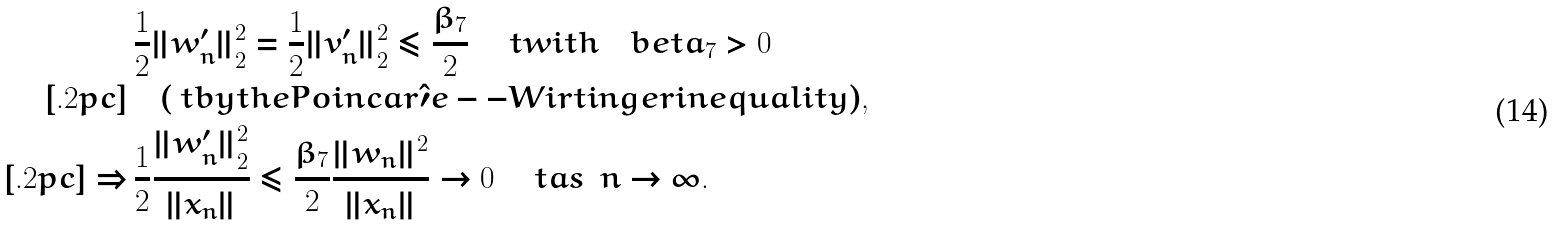Convert formula to latex. <formula><loc_0><loc_0><loc_500><loc_500>\ & \, \frac { 1 } { 2 } \| w _ { n } ^ { \prime } \| _ { 2 } ^ { 2 } = \frac { 1 } { 2 } \| v _ { n } ^ { \prime } \| _ { 2 } ^ { 2 } \leq \frac { \beta _ { 7 } } { 2 } \quad \ t { w i t h } \quad b e t a _ { 7 } > 0 \ \\ [ . 2 p c ] & \quad ( \ t { b y t h e P o i n c a r \hat { \prime } e - - W i r t i n g e r i n e q u a l i t y } ) , \\ [ . 2 p c ] \Rightarrow & \, \frac { 1 } { 2 } \frac { \| w _ { n } ^ { \prime } \| _ { 2 } ^ { 2 } } { \| x _ { n } \| } \leq \frac { \beta _ { 7 } } { 2 } \frac { \| w _ { n } \| ^ { 2 } } { \| x _ { n } \| } \rightarrow 0 \quad \ t { a s } \ \ n \rightarrow \infty .</formula> 